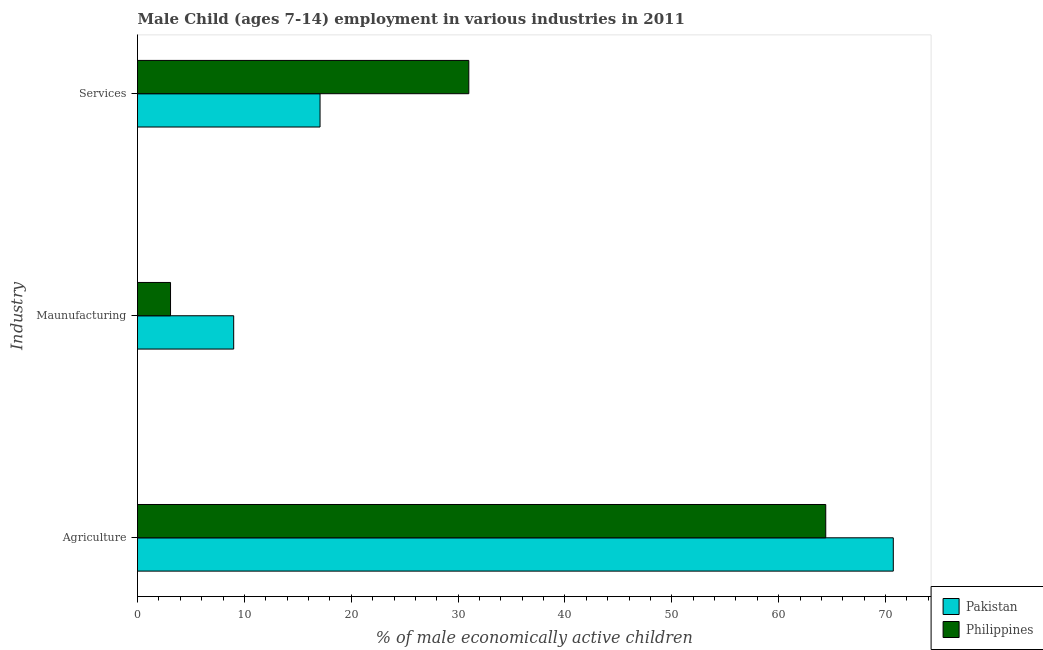How many different coloured bars are there?
Your response must be concise. 2. How many groups of bars are there?
Provide a short and direct response. 3. How many bars are there on the 1st tick from the bottom?
Make the answer very short. 2. What is the label of the 3rd group of bars from the top?
Keep it short and to the point. Agriculture. What is the percentage of economically active children in agriculture in Pakistan?
Provide a short and direct response. 70.72. Across all countries, what is the maximum percentage of economically active children in agriculture?
Provide a short and direct response. 70.72. Across all countries, what is the minimum percentage of economically active children in agriculture?
Ensure brevity in your answer.  64.4. In which country was the percentage of economically active children in services maximum?
Offer a very short reply. Philippines. What is the total percentage of economically active children in agriculture in the graph?
Ensure brevity in your answer.  135.12. What is the difference between the percentage of economically active children in agriculture in Philippines and that in Pakistan?
Your answer should be compact. -6.32. What is the difference between the percentage of economically active children in agriculture in Philippines and the percentage of economically active children in services in Pakistan?
Provide a succinct answer. 47.32. What is the average percentage of economically active children in manufacturing per country?
Your answer should be compact. 6.04. What is the difference between the percentage of economically active children in manufacturing and percentage of economically active children in services in Philippines?
Provide a succinct answer. -27.91. What is the ratio of the percentage of economically active children in services in Philippines to that in Pakistan?
Offer a very short reply. 1.81. Is the difference between the percentage of economically active children in services in Philippines and Pakistan greater than the difference between the percentage of economically active children in manufacturing in Philippines and Pakistan?
Provide a short and direct response. Yes. What is the difference between the highest and the second highest percentage of economically active children in agriculture?
Offer a terse response. 6.32. What is the difference between the highest and the lowest percentage of economically active children in agriculture?
Ensure brevity in your answer.  6.32. Is the sum of the percentage of economically active children in manufacturing in Philippines and Pakistan greater than the maximum percentage of economically active children in agriculture across all countries?
Offer a very short reply. No. Are all the bars in the graph horizontal?
Offer a very short reply. Yes. Are the values on the major ticks of X-axis written in scientific E-notation?
Give a very brief answer. No. Does the graph contain any zero values?
Ensure brevity in your answer.  No. Does the graph contain grids?
Offer a terse response. No. How many legend labels are there?
Your answer should be very brief. 2. How are the legend labels stacked?
Provide a succinct answer. Vertical. What is the title of the graph?
Provide a short and direct response. Male Child (ages 7-14) employment in various industries in 2011. What is the label or title of the X-axis?
Give a very brief answer. % of male economically active children. What is the label or title of the Y-axis?
Provide a short and direct response. Industry. What is the % of male economically active children in Pakistan in Agriculture?
Ensure brevity in your answer.  70.72. What is the % of male economically active children in Philippines in Agriculture?
Ensure brevity in your answer.  64.4. What is the % of male economically active children of Pakistan in Maunufacturing?
Provide a short and direct response. 9. What is the % of male economically active children in Philippines in Maunufacturing?
Offer a very short reply. 3.09. What is the % of male economically active children in Pakistan in Services?
Keep it short and to the point. 17.08. Across all Industry, what is the maximum % of male economically active children in Pakistan?
Ensure brevity in your answer.  70.72. Across all Industry, what is the maximum % of male economically active children in Philippines?
Offer a terse response. 64.4. Across all Industry, what is the minimum % of male economically active children in Pakistan?
Provide a succinct answer. 9. Across all Industry, what is the minimum % of male economically active children in Philippines?
Your answer should be compact. 3.09. What is the total % of male economically active children of Pakistan in the graph?
Give a very brief answer. 96.8. What is the total % of male economically active children of Philippines in the graph?
Your response must be concise. 98.49. What is the difference between the % of male economically active children in Pakistan in Agriculture and that in Maunufacturing?
Offer a terse response. 61.72. What is the difference between the % of male economically active children in Philippines in Agriculture and that in Maunufacturing?
Your response must be concise. 61.31. What is the difference between the % of male economically active children of Pakistan in Agriculture and that in Services?
Your answer should be compact. 53.64. What is the difference between the % of male economically active children of Philippines in Agriculture and that in Services?
Keep it short and to the point. 33.4. What is the difference between the % of male economically active children in Pakistan in Maunufacturing and that in Services?
Give a very brief answer. -8.08. What is the difference between the % of male economically active children in Philippines in Maunufacturing and that in Services?
Provide a succinct answer. -27.91. What is the difference between the % of male economically active children in Pakistan in Agriculture and the % of male economically active children in Philippines in Maunufacturing?
Offer a very short reply. 67.63. What is the difference between the % of male economically active children of Pakistan in Agriculture and the % of male economically active children of Philippines in Services?
Provide a succinct answer. 39.72. What is the average % of male economically active children in Pakistan per Industry?
Your response must be concise. 32.27. What is the average % of male economically active children in Philippines per Industry?
Make the answer very short. 32.83. What is the difference between the % of male economically active children in Pakistan and % of male economically active children in Philippines in Agriculture?
Your answer should be very brief. 6.32. What is the difference between the % of male economically active children of Pakistan and % of male economically active children of Philippines in Maunufacturing?
Your answer should be very brief. 5.91. What is the difference between the % of male economically active children of Pakistan and % of male economically active children of Philippines in Services?
Provide a succinct answer. -13.92. What is the ratio of the % of male economically active children in Pakistan in Agriculture to that in Maunufacturing?
Make the answer very short. 7.86. What is the ratio of the % of male economically active children in Philippines in Agriculture to that in Maunufacturing?
Offer a terse response. 20.84. What is the ratio of the % of male economically active children in Pakistan in Agriculture to that in Services?
Your answer should be very brief. 4.14. What is the ratio of the % of male economically active children of Philippines in Agriculture to that in Services?
Your answer should be very brief. 2.08. What is the ratio of the % of male economically active children in Pakistan in Maunufacturing to that in Services?
Give a very brief answer. 0.53. What is the ratio of the % of male economically active children of Philippines in Maunufacturing to that in Services?
Offer a very short reply. 0.1. What is the difference between the highest and the second highest % of male economically active children of Pakistan?
Give a very brief answer. 53.64. What is the difference between the highest and the second highest % of male economically active children in Philippines?
Your response must be concise. 33.4. What is the difference between the highest and the lowest % of male economically active children in Pakistan?
Make the answer very short. 61.72. What is the difference between the highest and the lowest % of male economically active children in Philippines?
Provide a succinct answer. 61.31. 